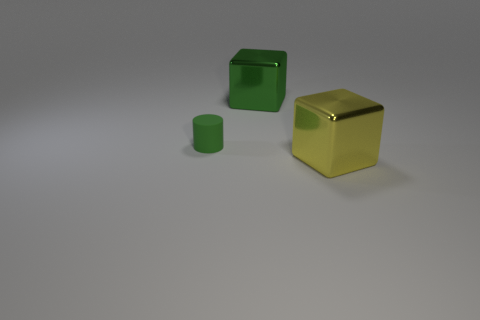Add 3 big green objects. How many objects exist? 6 Subtract 0 green balls. How many objects are left? 3 Subtract all cylinders. How many objects are left? 2 Subtract 1 cylinders. How many cylinders are left? 0 Subtract all blue cylinders. Subtract all blue cubes. How many cylinders are left? 1 Subtract all cyan cubes. How many gray cylinders are left? 0 Subtract all tiny things. Subtract all big yellow shiny blocks. How many objects are left? 1 Add 3 green shiny cubes. How many green shiny cubes are left? 4 Add 1 big things. How many big things exist? 3 Subtract all green cubes. How many cubes are left? 1 